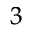<formula> <loc_0><loc_0><loc_500><loc_500>^ { 3 }</formula> 